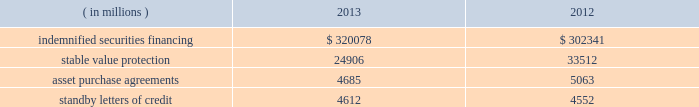State street corporation notes to consolidated financial statements ( continued ) with respect to the 5.25% ( 5.25 % ) subordinated bank notes due 2018 , state street bank is required to make semi- annual interest payments on the outstanding principal balance of the notes on april 15 and october 15 of each year , and the notes qualify for inclusion in tier 2 regulatory capital under current federal regulatory capital guidelines .
With respect to the 5.30% ( 5.30 % ) subordinated notes due 2016 and the floating-rate subordinated notes due 2015 , state street bank is required to make semi-annual interest payments on the outstanding principal balance of the 5.30% ( 5.30 % ) subordinated notes on january 15 and july 15 of each year , and quarterly interest payments on the outstanding principal balance of the floating-rate notes on march 8 , june 8 , september 8 and december 8 of each year .
Each of the subordinated notes qualifies for inclusion in tier 2 regulatory capital under current federal regulatory capital guidelines .
Note 11 .
Commitments , guarantees and contingencies commitments : we had unfunded off-balance sheet commitments to extend credit totaling $ 21.30 billion and $ 17.86 billion as of december 31 , 2013 and 2012 , respectively .
The potential losses associated with these commitments equal the gross contractual amounts , and do not consider the value of any collateral .
Approximately 75% ( 75 % ) of our unfunded commitments to extend credit expire within one year from the date of issue .
Since many of these commitments are expected to expire or renew without being drawn upon , the gross contractual amounts do not necessarily represent our future cash requirements .
Guarantees : off-balance sheet guarantees are composed of indemnified securities financing , stable value protection , unfunded commitments to purchase assets , and standby letters of credit .
The potential losses associated with these guarantees equal the gross contractual amounts , and do not consider the value of any collateral .
The table presents the aggregate gross contractual amounts of our off-balance sheet guarantees as of december 31 , 2013 and 2012 .
Amounts presented do not reflect participations to independent third parties. .
Indemnified securities financing on behalf of our clients , we lend their securities , as agent , to brokers and other institutions .
In most circumstances , we indemnify our clients for the fair market value of those securities against a failure of the borrower to return such securities .
We require the borrowers to maintain collateral in an amount equal to or in excess of 100% ( 100 % ) of the fair market value of the securities borrowed .
Securities on loan and the collateral are revalued daily to determine if additional collateral is necessary or if excess collateral is required to be returned to the borrower .
Collateral received in connection with our securities lending services is held by us as agent and is not recorded in our consolidated statement of condition .
The cash collateral held by us as agent is invested on behalf of our clients .
In certain cases , the cash collateral is invested in third-party repurchase agreements , for which we indemnify the client against loss of the principal invested .
We require the counterparty to the indemnified repurchase agreement to provide collateral in an amount equal to or in excess of 100% ( 100 % ) of the amount of the repurchase agreement .
In our role as agent , the indemnified repurchase agreements and the related collateral held by us are not recorded in our consolidated statement of condition. .
What is the percentage change in the balance related to stable value protection from 2012 to 2013? 
Computations: ((24906 - 33512) / 33512)
Answer: -0.2568. 